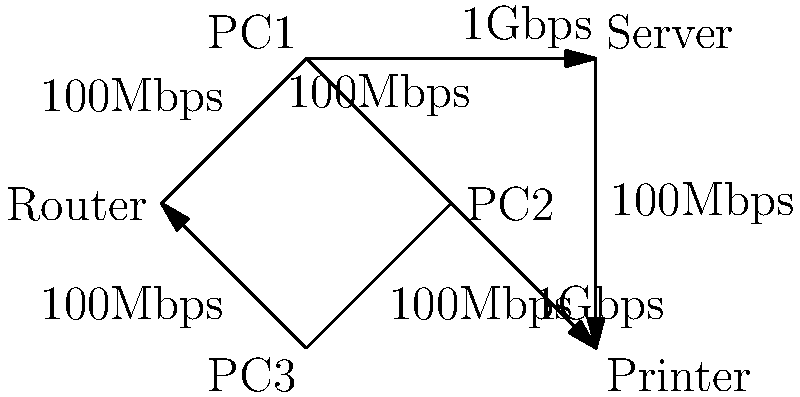In the given home network diagram, what is the maximum theoretical bandwidth for data transfer between PC1 and the Printer, assuming all other devices are idle? To determine the maximum theoretical bandwidth between PC1 and the Printer, we need to analyze the path and identify the bottleneck:

1. Trace the path from PC1 to Printer:
   PC1 → Router → PC2 → Printer

2. Identify the bandwidth of each connection:
   PC1 to Router: 100 Mbps
   Router to PC2: 100 Mbps
   PC2 to Printer: 1 Gbps

3. The overall bandwidth of a path is limited by its slowest link (bottleneck).

4. In this case, there are two 100 Mbps links and one 1 Gbps link.

5. The 100 Mbps links are the bottlenecks in this path.

Therefore, the maximum theoretical bandwidth for data transfer between PC1 and the Printer is limited by the slowest link in the path, which is 100 Mbps.
Answer: 100 Mbps 